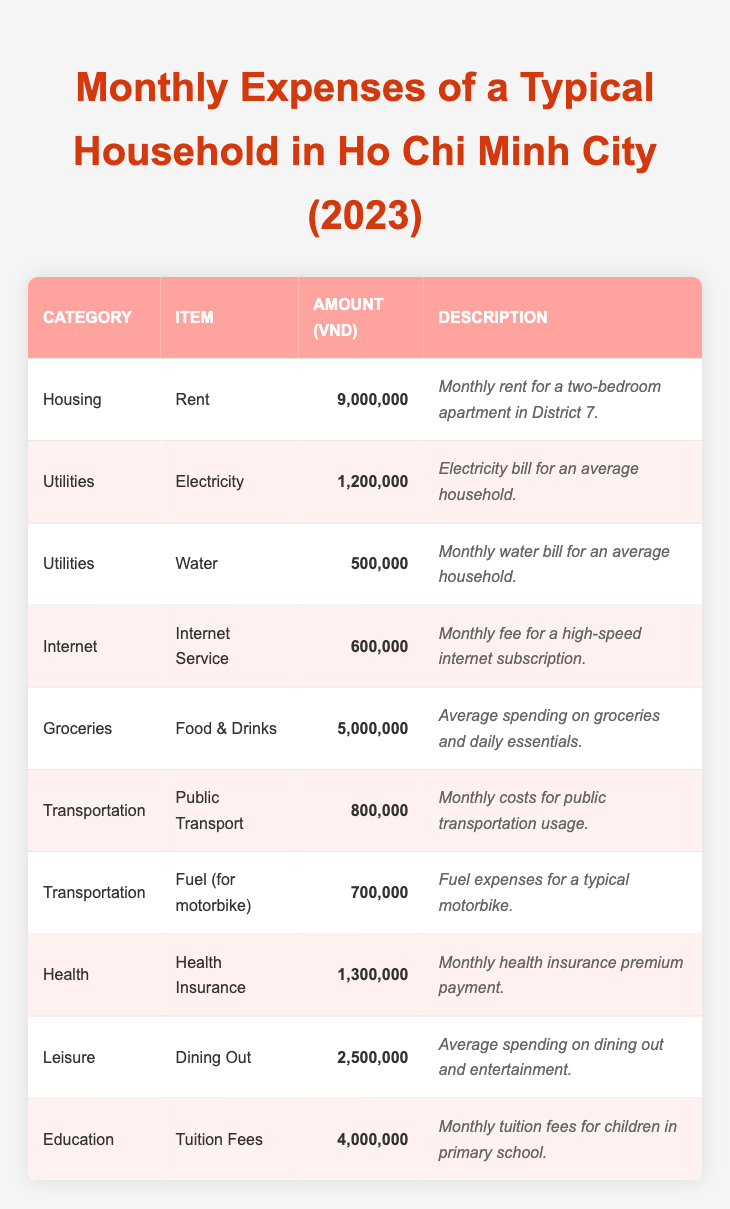What's the total amount spent on Utilities? The total amount for Utilities includes Electricity (1,200,000 VND) and Water (500,000 VND). Adding these gives 1,200,000 + 500,000 = 1,700,000 VND.
Answer: 1,700,000 VND How much is spent on Transportation? The Transportation expenses consist of two items: Public Transport (800,000 VND) and Fuel (700,000 VND). Summing these amounts results in 800,000 + 700,000 = 1,500,000 VND.
Answer: 1,500,000 VND Is the average spending on Dining Out less than 3,000,000 VND? The amount spent on Dining Out is 2,500,000 VND, which is indeed less than 3,000,000 VND.
Answer: Yes What is the total monthly expense for Education and Health combined? The monthly expenses for Education (4,000,000 VND) and Health (1,300,000 VND) are added together: 4,000,000 + 1,300,000 = 5,300,000 VND.
Answer: 5,300,000 VND How much more does a household spend on Rent than on Internet Service? Rent is 9,000,000 VND and Internet Service is 600,000 VND. The difference is 9,000,000 - 600,000 = 8,400,000 VND more spent on Rent.
Answer: 8,400,000 VND If we average the monthly expenses from all categories, what is the result? The total monthly expenses across all categories can be summed up: 9,000,000 + 1,200,000 + 500,000 + 600,000 + 5,000,000 + 800,000 + 700,000 + 1,300,000 + 2,500,000 + 4,000,000 = 27,100,000 VND. There are 10 items, so the average is 27,100,000 / 10 = 2,710,000 VND.
Answer: 2,710,000 VND What is the item with the highest monthly expense? Looking at the amounts, Rent (9,000,000 VND) is the highest compared to other items.
Answer: Rent Is the cost of Health Insurance equal to the sum of the Electricity and Water bills? The Health Insurance is 1,300,000 VND while the sum of Electricity (1,200,000 VND) and Water (500,000 VND) is 1,700,000 VND. Since 1,300,000 is not equal to 1,700,000, the statement is false.
Answer: No How much does a typical household spend on Groceries compared to Leisure? Groceries cost 5,000,000 VND and Leisure (Dining Out) costs 2,500,000 VND. The difference is 5,000,000 - 2,500,000 = 2,500,000 VND more spent on Groceries.
Answer: 2,500,000 VND What percentage of the total expenses is allocated to Housing? The total expenses are calculated as 27,100,000 VND. The amount for Housing (Rent) is 9,000,000 VND. The percentage is (9,000,000 / 27,100,000) * 100 = 33.2%.
Answer: 33.2% 